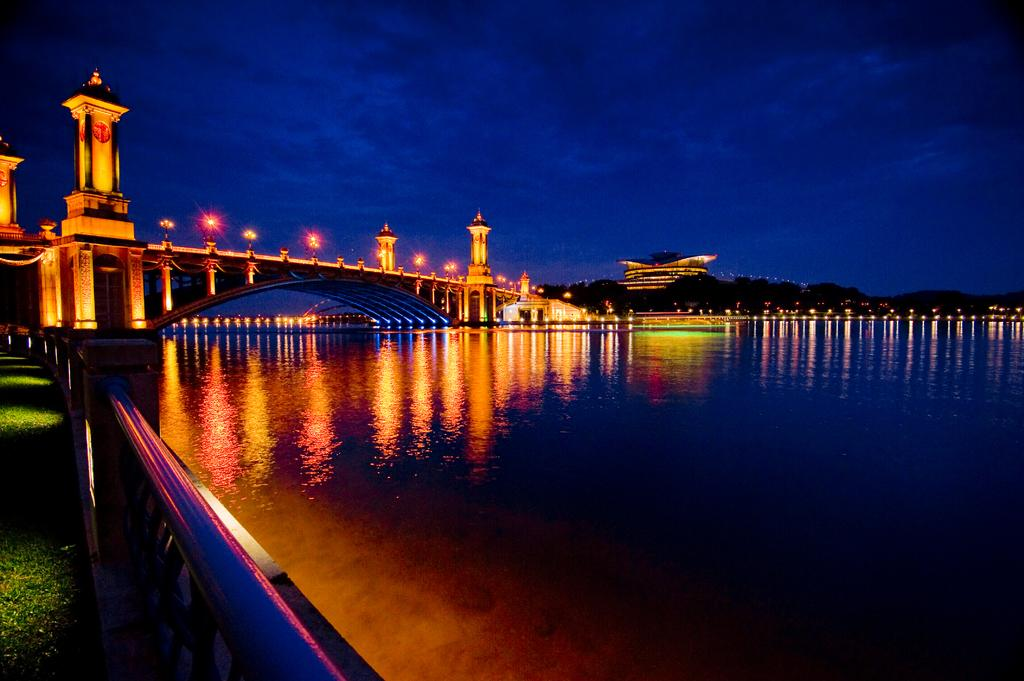What can be seen in the image that might be used for support or safety? There is a railing in the image that might be used for support or safety. What natural element is visible in the image? There is water visible in the image. What can be seen in the background of the image that might indicate human presence or activity? There are buildings with lights in the background of the image. What type of vegetation is visible in the background of the image? There are trees in the background of the image. What part of the natural environment is visible in the image? The sky is visible in the background of the image. What instrument is the queen playing in the image? There is no queen or instrument present in the image. 